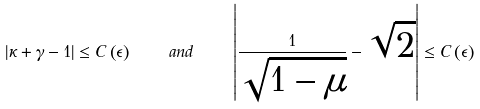<formula> <loc_0><loc_0><loc_500><loc_500>| \kappa + \gamma - 1 | \leq C \left ( \epsilon \right ) \quad a n d \quad \left | \frac { 1 } { \sqrt { 1 - \mu } } - \sqrt { 2 } \right | \leq C \left ( \epsilon \right )</formula> 